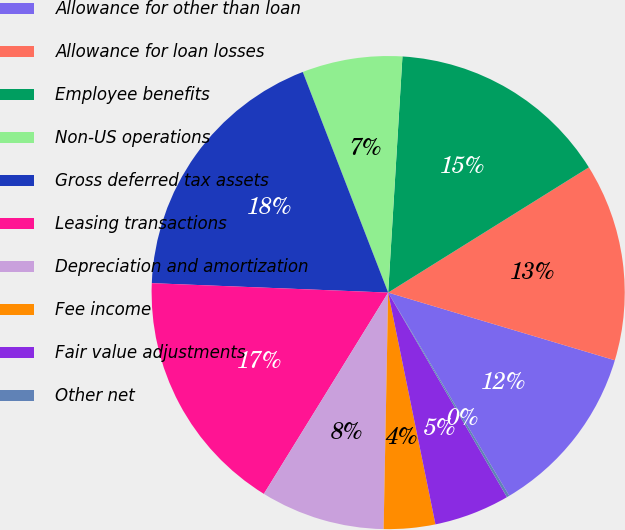Convert chart. <chart><loc_0><loc_0><loc_500><loc_500><pie_chart><fcel>Allowance for other than loan<fcel>Allowance for loan losses<fcel>Employee benefits<fcel>Non-US operations<fcel>Gross deferred tax assets<fcel>Leasing transactions<fcel>Depreciation and amortization<fcel>Fee income<fcel>Fair value adjustments<fcel>Other net<nl><fcel>11.83%<fcel>13.5%<fcel>15.16%<fcel>6.84%<fcel>18.49%<fcel>16.83%<fcel>8.5%<fcel>3.51%<fcel>5.17%<fcel>0.18%<nl></chart> 